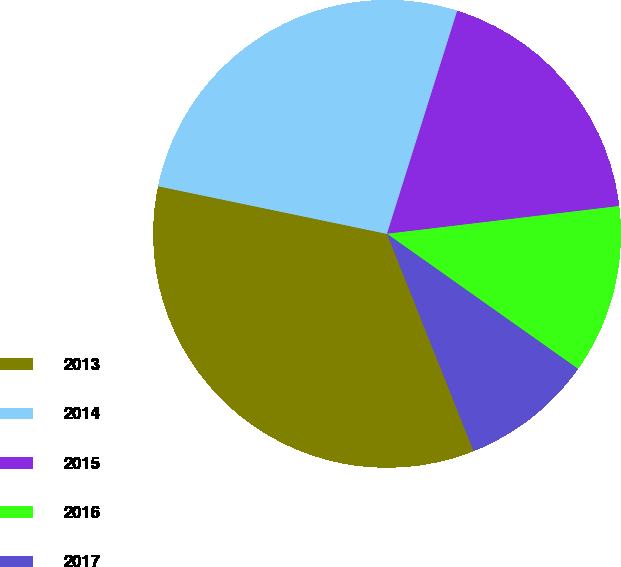<chart> <loc_0><loc_0><loc_500><loc_500><pie_chart><fcel>2013<fcel>2014<fcel>2015<fcel>2016<fcel>2017<nl><fcel>34.3%<fcel>26.59%<fcel>18.25%<fcel>11.69%<fcel>9.17%<nl></chart> 